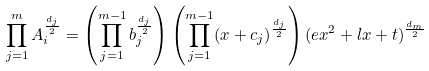<formula> <loc_0><loc_0><loc_500><loc_500>\prod _ { j = 1 } ^ { m } A _ { i } ^ { \frac { d _ { j } } { 2 } } = \left ( \prod _ { j = 1 } ^ { m - 1 } b _ { j } ^ { \frac { d _ { j } } { 2 } } \right ) \left ( \prod _ { j = 1 } ^ { m - 1 } ( x + c _ { j } ) ^ { \frac { d _ { j } } { 2 } } \right ) ( e x ^ { 2 } + l x + t ) ^ { \frac { d _ { m } } { 2 } }</formula> 